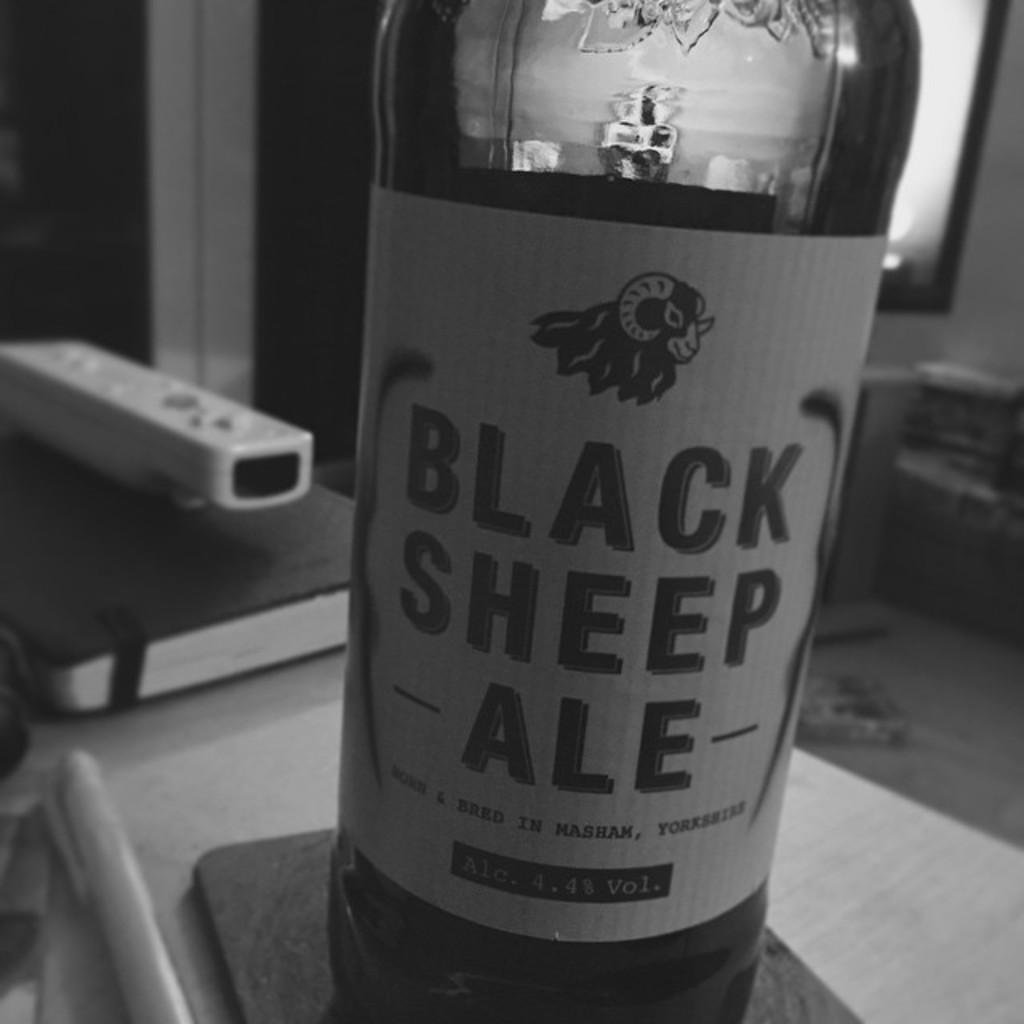What percent alcohol is in the ale?
Your response must be concise. 4.4%. What is the first word printed at the top of this ale?
Make the answer very short. Black. 